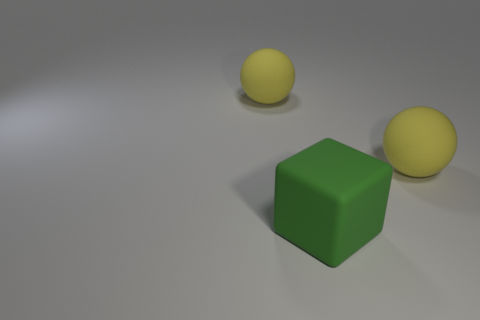Can you describe the lighting and the shadows in the image? The lighting in the image is soft and diffused, casting gentle shadows directly under and slightly to the right of the objects, indicating a light source from the top left. 